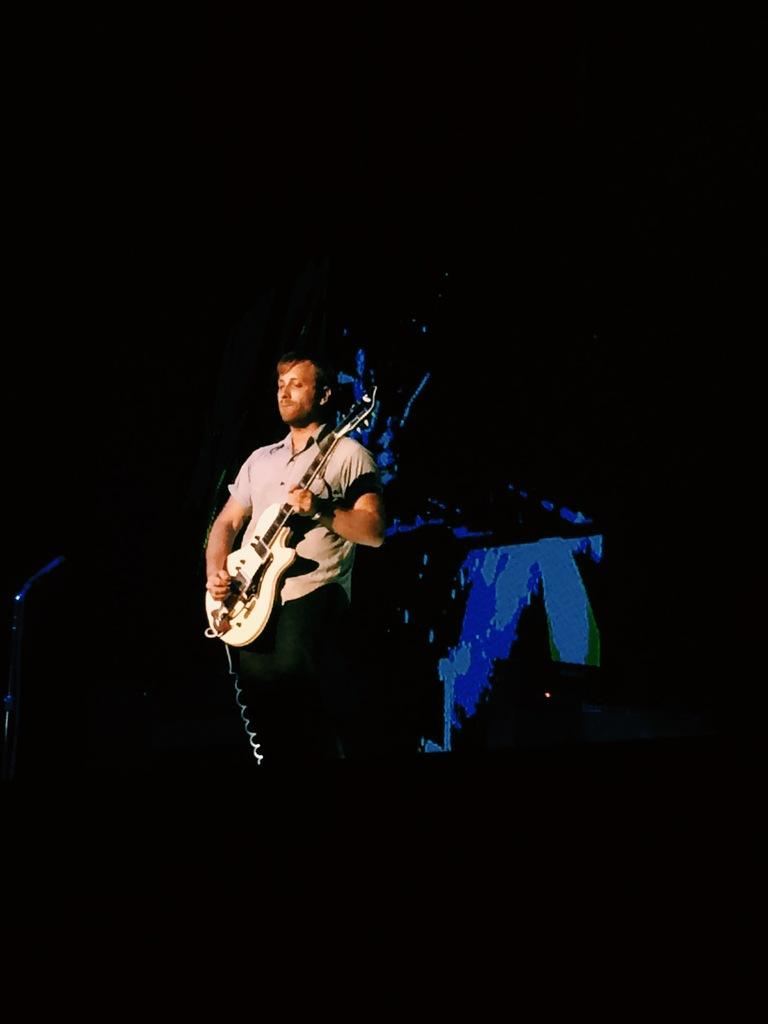What is the main subject of the image? The main subject of the image is a person. What is the person doing in the image? The person is standing and playing a guitar. What can be observed about the background of the image? The background of the image is dark. What type of oil is being used by the person in the image? There is no indication in the image that the person is using any oil, as they are playing a guitar. How much money is the person earning while playing the guitar in the image? There is no information about the person's earnings in the image, as it only shows them playing a guitar. 